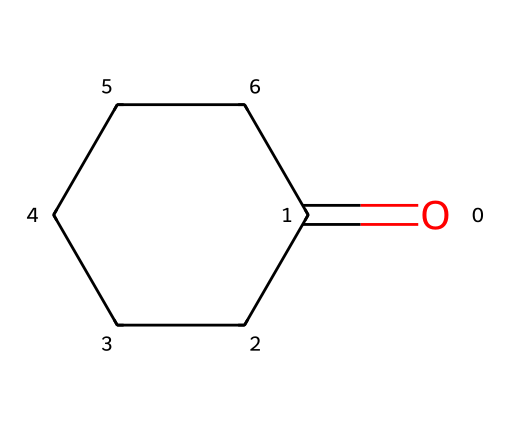What is the molecular formula of cyclohexanone? To find the molecular formula, you can count the number of carbon (C), hydrogen (H), and oxygen (O) atoms in the structure. The SMILES representation indicates there are 6 carbons, 10 hydrogens, and 1 oxygen. Therefore, the molecular formula consists of these counts.
Answer: C6H10O How many carbon atoms are in cyclohexanone? The structure contains a cyclohexane ring which indicates there are 6 carbon atoms present in the molecule. Counting the atoms from the SMILES representation shows a total of 6 carbon atoms.
Answer: 6 What type of functional group is present in cyclohexanone? The SMILES structure features a carbonyl group (C=O) attached to a cyclic structure, which is characteristic of ketones. Therefore, it indicates the functional group is a ketone.
Answer: ketone How many hydrogen atoms are bonded to the carbon atoms in cyclohexanone? In the cyclohexanone structure, each of the 6 carbon atoms forms bonds, achieving a total of 10 hydrogens. This can be confirmed by evaluating the valency of carbon and how hydrogens fit into the structure.
Answer: 10 Is cyclohexanone a saturated or unsaturated compound? The presence of a carbonyl group makes the compound a ketone, which does not introduce unsaturation in the usual sense, but the overall structure does not contain any double bonds between carbon atoms. This confirms it is saturated.
Answer: saturated What is the significance of cyclohexanone in industrial applications? Cyclohexanone is used as a solvent and an intermediate in nylon production, especially in applications for computer accessories. Its ketone functional group is useful in polymerization processes.
Answer: nylon production 